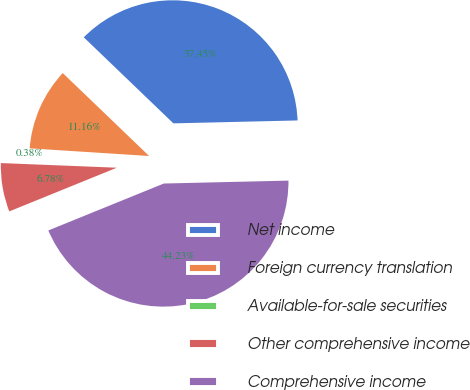Convert chart. <chart><loc_0><loc_0><loc_500><loc_500><pie_chart><fcel>Net income<fcel>Foreign currency translation<fcel>Available-for-sale securities<fcel>Other comprehensive income<fcel>Comprehensive income<nl><fcel>37.45%<fcel>11.16%<fcel>0.38%<fcel>6.78%<fcel>44.23%<nl></chart> 